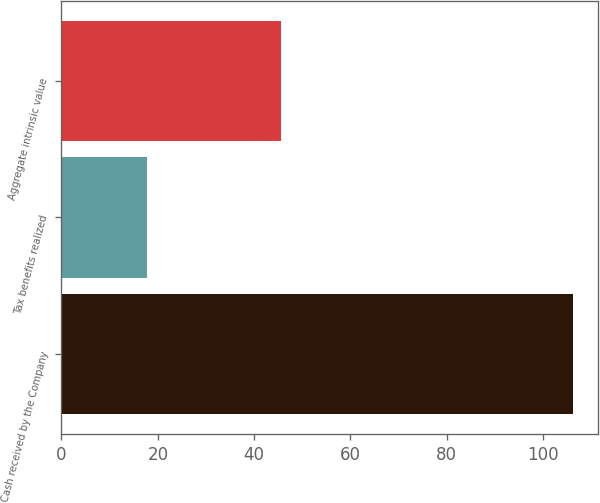Convert chart. <chart><loc_0><loc_0><loc_500><loc_500><bar_chart><fcel>Cash received by the Company<fcel>Tax benefits realized<fcel>Aggregate intrinsic value<nl><fcel>106.1<fcel>17.7<fcel>45.5<nl></chart> 